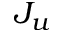<formula> <loc_0><loc_0><loc_500><loc_500>J _ { u }</formula> 